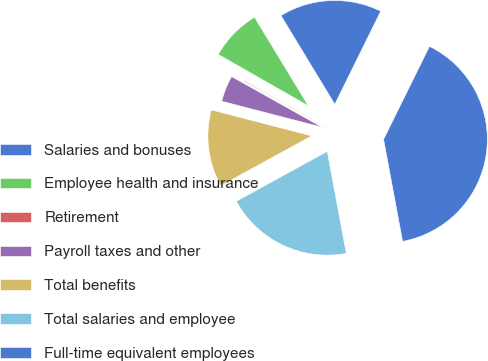<chart> <loc_0><loc_0><loc_500><loc_500><pie_chart><fcel>Salaries and bonuses<fcel>Employee health and insurance<fcel>Retirement<fcel>Payroll taxes and other<fcel>Total benefits<fcel>Total salaries and employee<fcel>Full-time equivalent employees<nl><fcel>15.98%<fcel>8.06%<fcel>0.13%<fcel>4.09%<fcel>12.02%<fcel>19.95%<fcel>39.77%<nl></chart> 